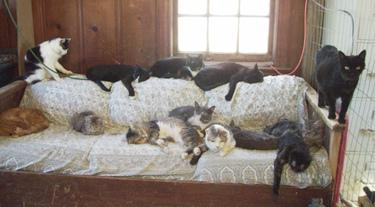What is the paneling made of which is covering the walls? Please explain your reasoning. pine. Knotty a is likely the correct answer because of the obvious knots. 